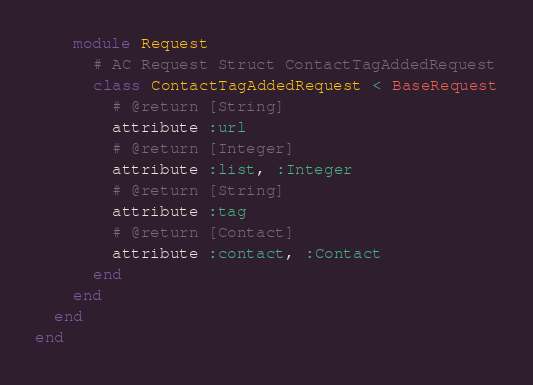Convert code to text. <code><loc_0><loc_0><loc_500><loc_500><_Ruby_>    module Request
      # AC Request Struct ContactTagAddedRequest
      class ContactTagAddedRequest < BaseRequest
        # @return [String]
        attribute :url
        # @return [Integer]
        attribute :list, :Integer
        # @return [String]
        attribute :tag
        # @return [Contact]
        attribute :contact, :Contact
      end
    end
  end
end
</code> 